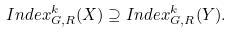<formula> <loc_0><loc_0><loc_500><loc_500>I n d e x _ { G , R } ^ { k } ( X ) \supseteq I n d e x _ { G , R } ^ { k } ( Y ) .</formula> 